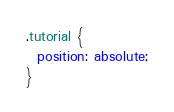Convert code to text. <code><loc_0><loc_0><loc_500><loc_500><_CSS_>.tutorial {
  position: absolute;
}
</code> 